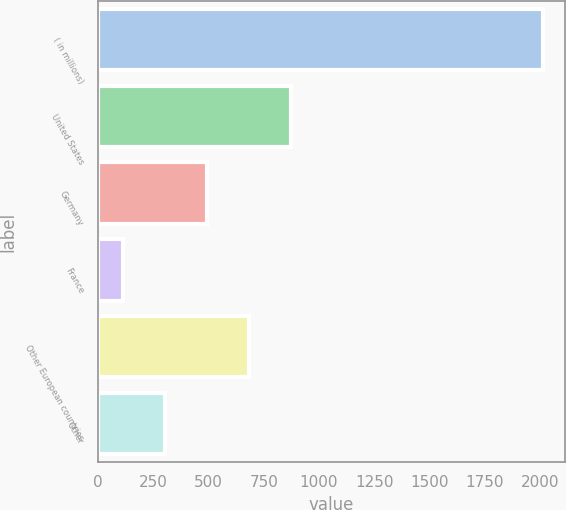Convert chart. <chart><loc_0><loc_0><loc_500><loc_500><bar_chart><fcel>( in millions)<fcel>United States<fcel>Germany<fcel>France<fcel>Other European countries<fcel>Other<nl><fcel>2013<fcel>872.76<fcel>492.68<fcel>112.6<fcel>682.72<fcel>302.64<nl></chart> 